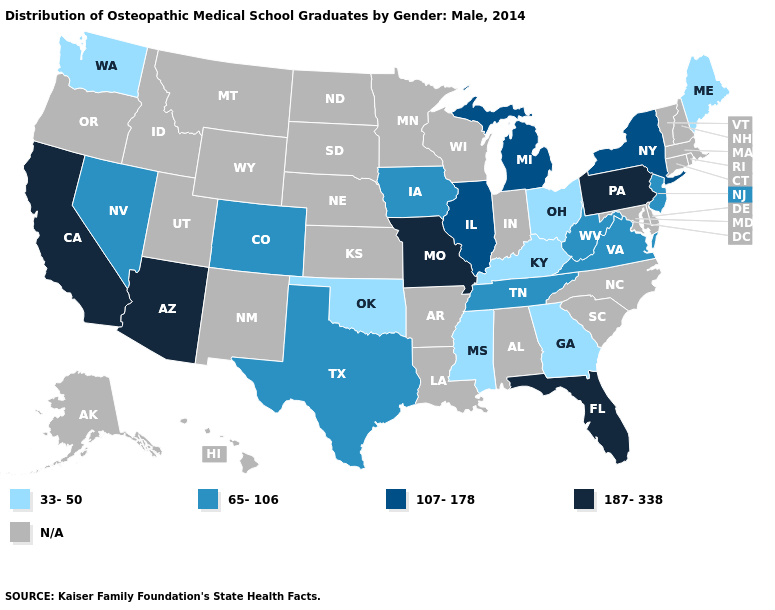Name the states that have a value in the range 107-178?
Keep it brief. Illinois, Michigan, New York. Name the states that have a value in the range 107-178?
Be succinct. Illinois, Michigan, New York. Among the states that border Connecticut , which have the highest value?
Write a very short answer. New York. Name the states that have a value in the range 65-106?
Short answer required. Colorado, Iowa, Nevada, New Jersey, Tennessee, Texas, Virginia, West Virginia. What is the value of Texas?
Quick response, please. 65-106. What is the value of West Virginia?
Keep it brief. 65-106. Name the states that have a value in the range 107-178?
Short answer required. Illinois, Michigan, New York. Which states hav the highest value in the West?
Concise answer only. Arizona, California. What is the value of Alabama?
Short answer required. N/A. Among the states that border Florida , which have the highest value?
Keep it brief. Georgia. Does New Jersey have the highest value in the USA?
Quick response, please. No. Name the states that have a value in the range 107-178?
Write a very short answer. Illinois, Michigan, New York. What is the value of Hawaii?
Write a very short answer. N/A. Which states have the highest value in the USA?
Quick response, please. Arizona, California, Florida, Missouri, Pennsylvania. 